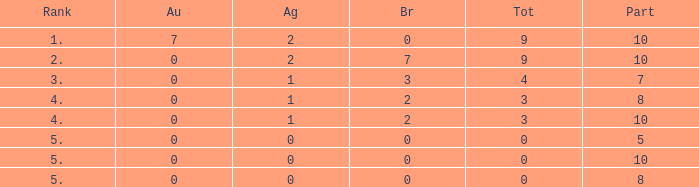What is the aggregate amount of participants holding silver with a negative value? None. 